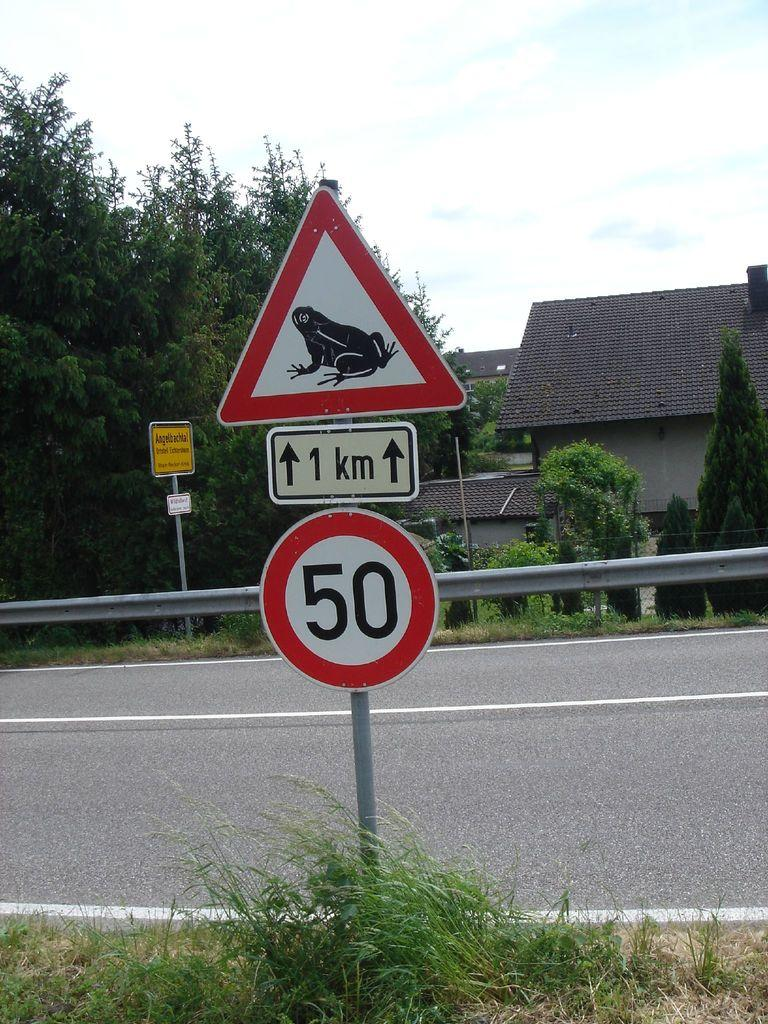<image>
Write a terse but informative summary of the picture. A street sign is shown near a road saying 1 km and 50 with a frog picture on the top one. 